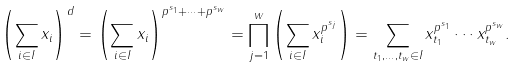Convert formula to latex. <formula><loc_0><loc_0><loc_500><loc_500>\left ( \sum _ { i \in I } x _ { i } \right ) ^ { d } = \left ( \sum _ { i \in I } x _ { i } \right ) ^ { p ^ { s _ { 1 } } + \cdots + p ^ { s _ { w } } } = \prod _ { j = 1 } ^ { w } \left ( \sum _ { i \in I } x _ { i } ^ { p ^ { s _ { j } } } \right ) = \sum _ { t _ { 1 } , \dots , t _ { w } \in I } x _ { t _ { 1 } } ^ { p ^ { s _ { 1 } } } \cdots x _ { t _ { w } } ^ { p ^ { s _ { w } } } .</formula> 